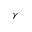<formula> <loc_0><loc_0><loc_500><loc_500>\gamma</formula> 